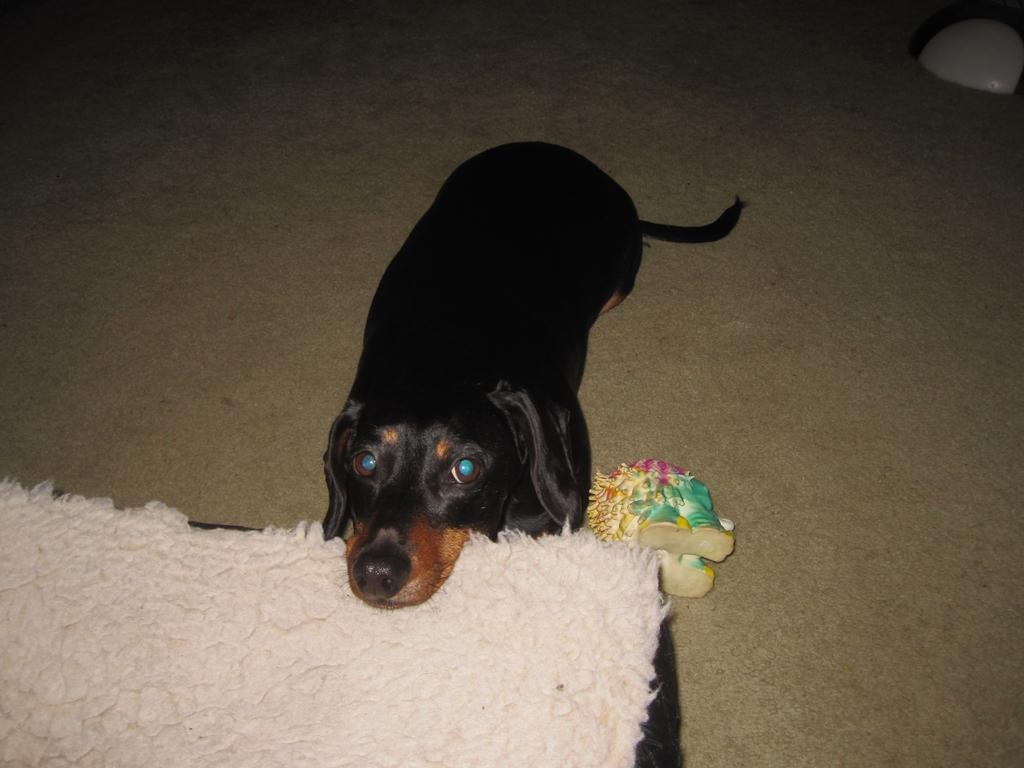In one or two sentences, can you explain what this image depicts? In this we can see a dog and bed. 